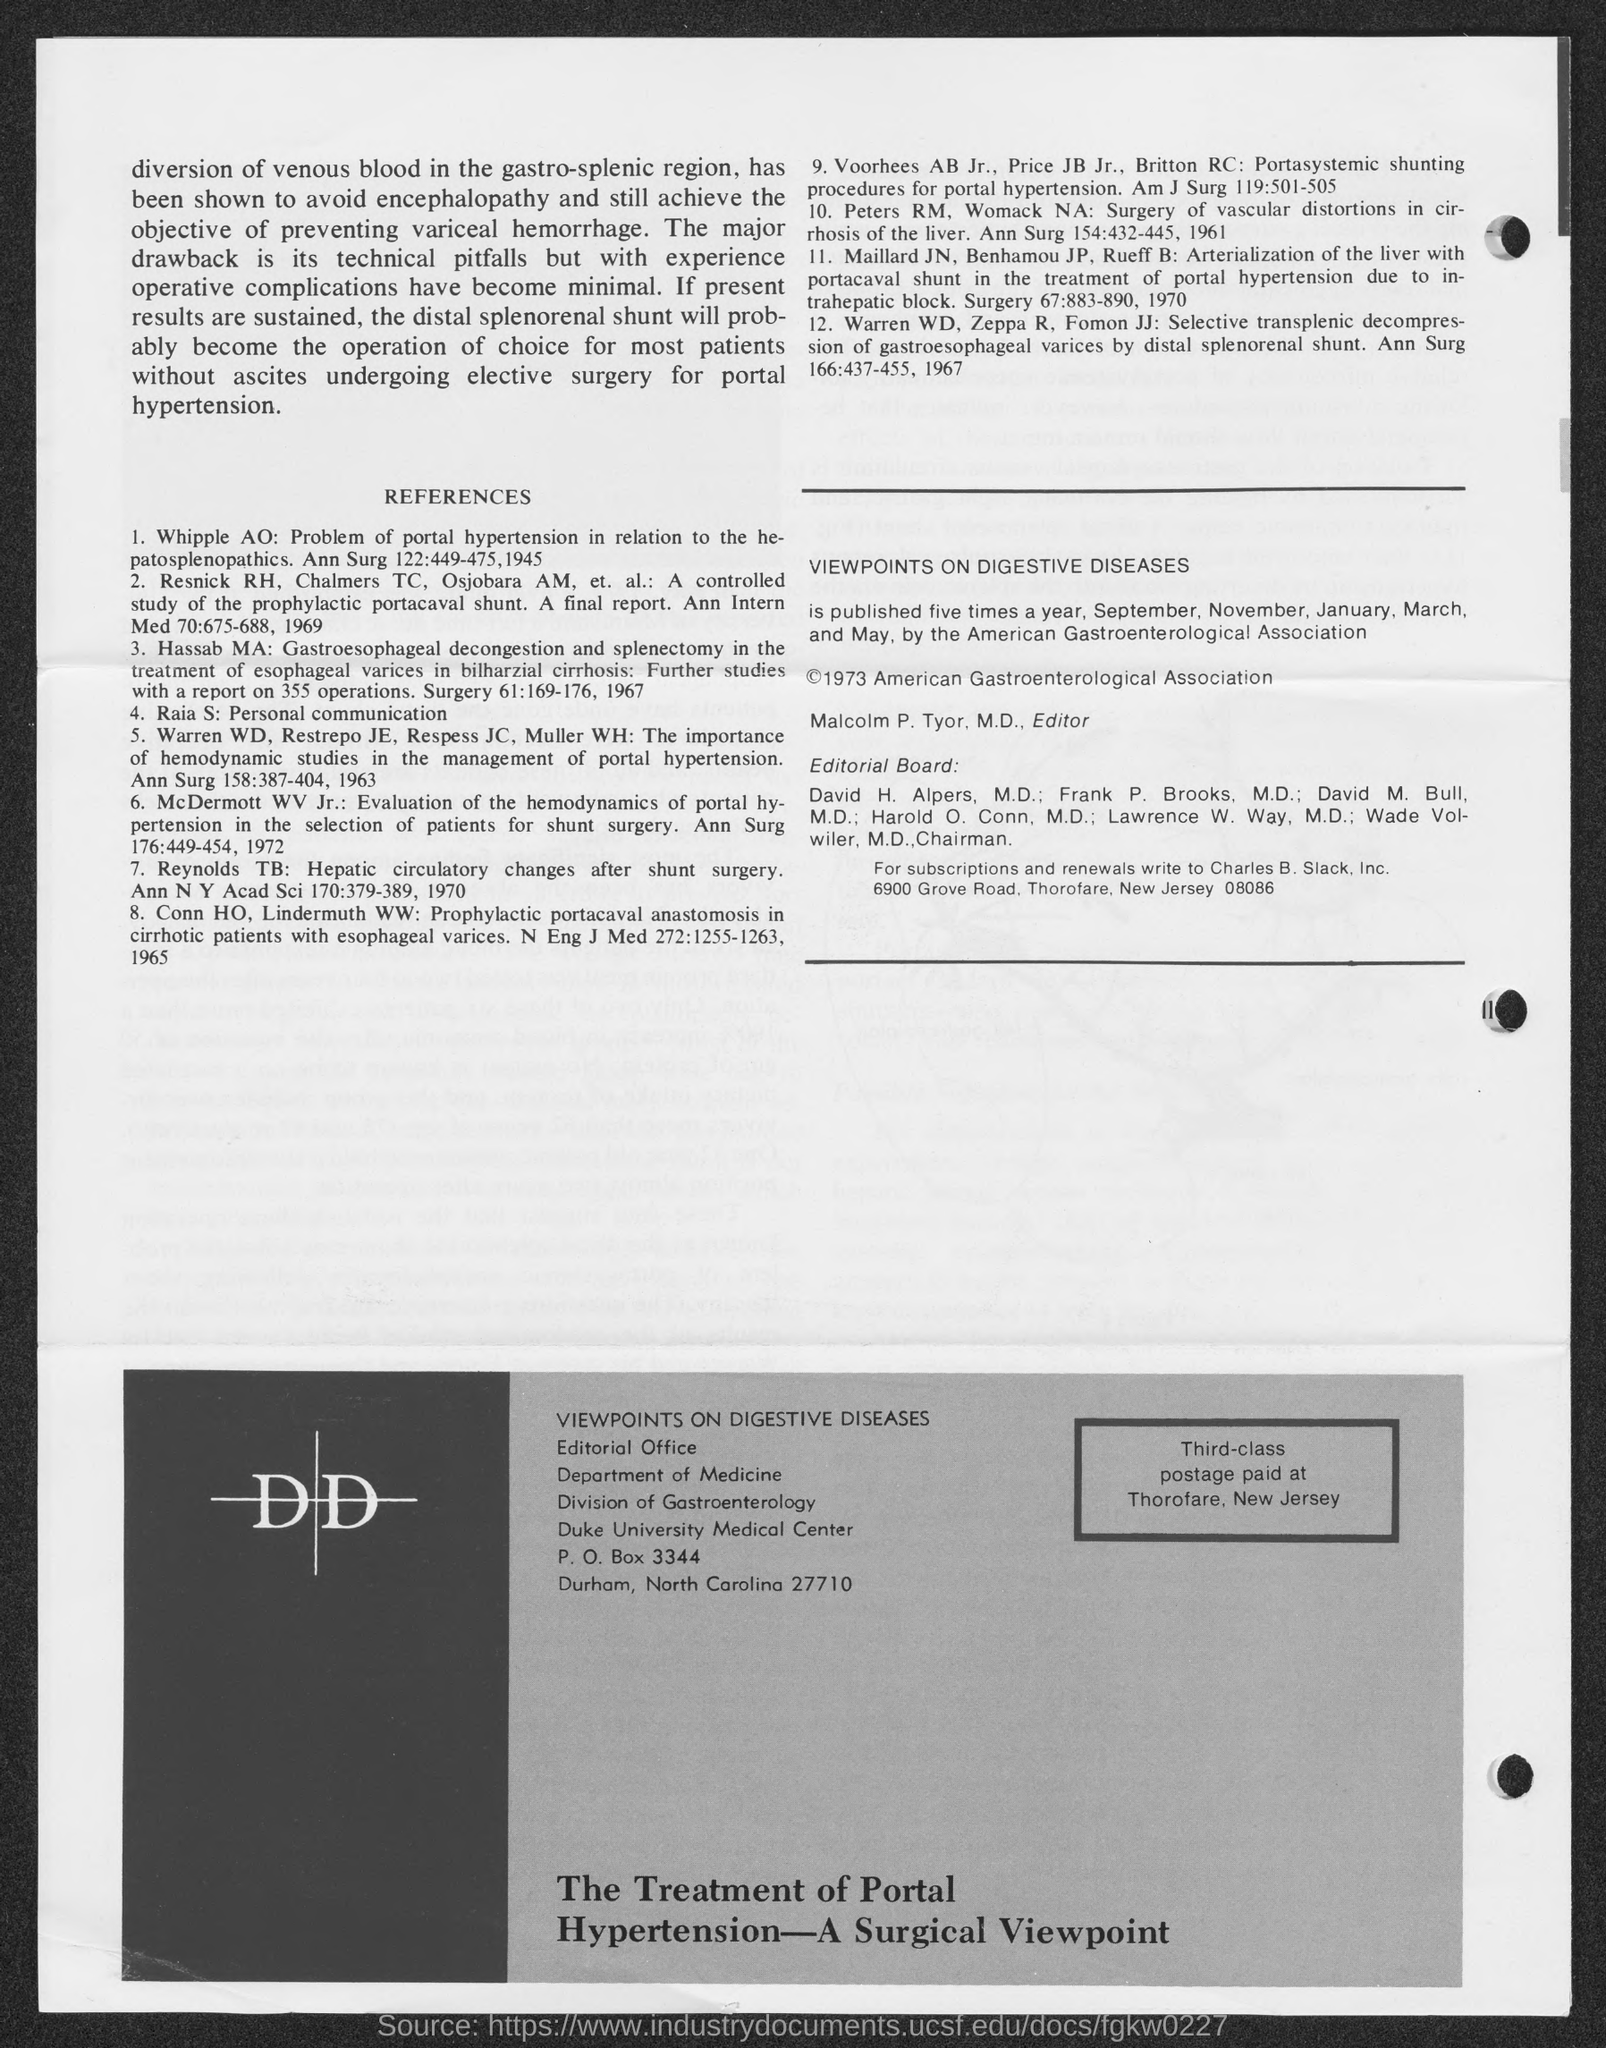Highlight a few significant elements in this photo. The PO Box number mentioned in the document is 3344. The first title in the document is 'References.' 